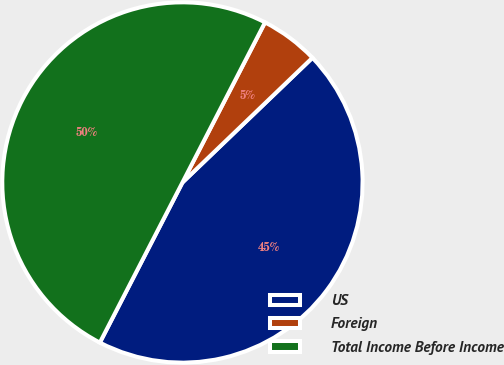Convert chart to OTSL. <chart><loc_0><loc_0><loc_500><loc_500><pie_chart><fcel>US<fcel>Foreign<fcel>Total Income Before Income<nl><fcel>44.75%<fcel>5.25%<fcel>50.0%<nl></chart> 